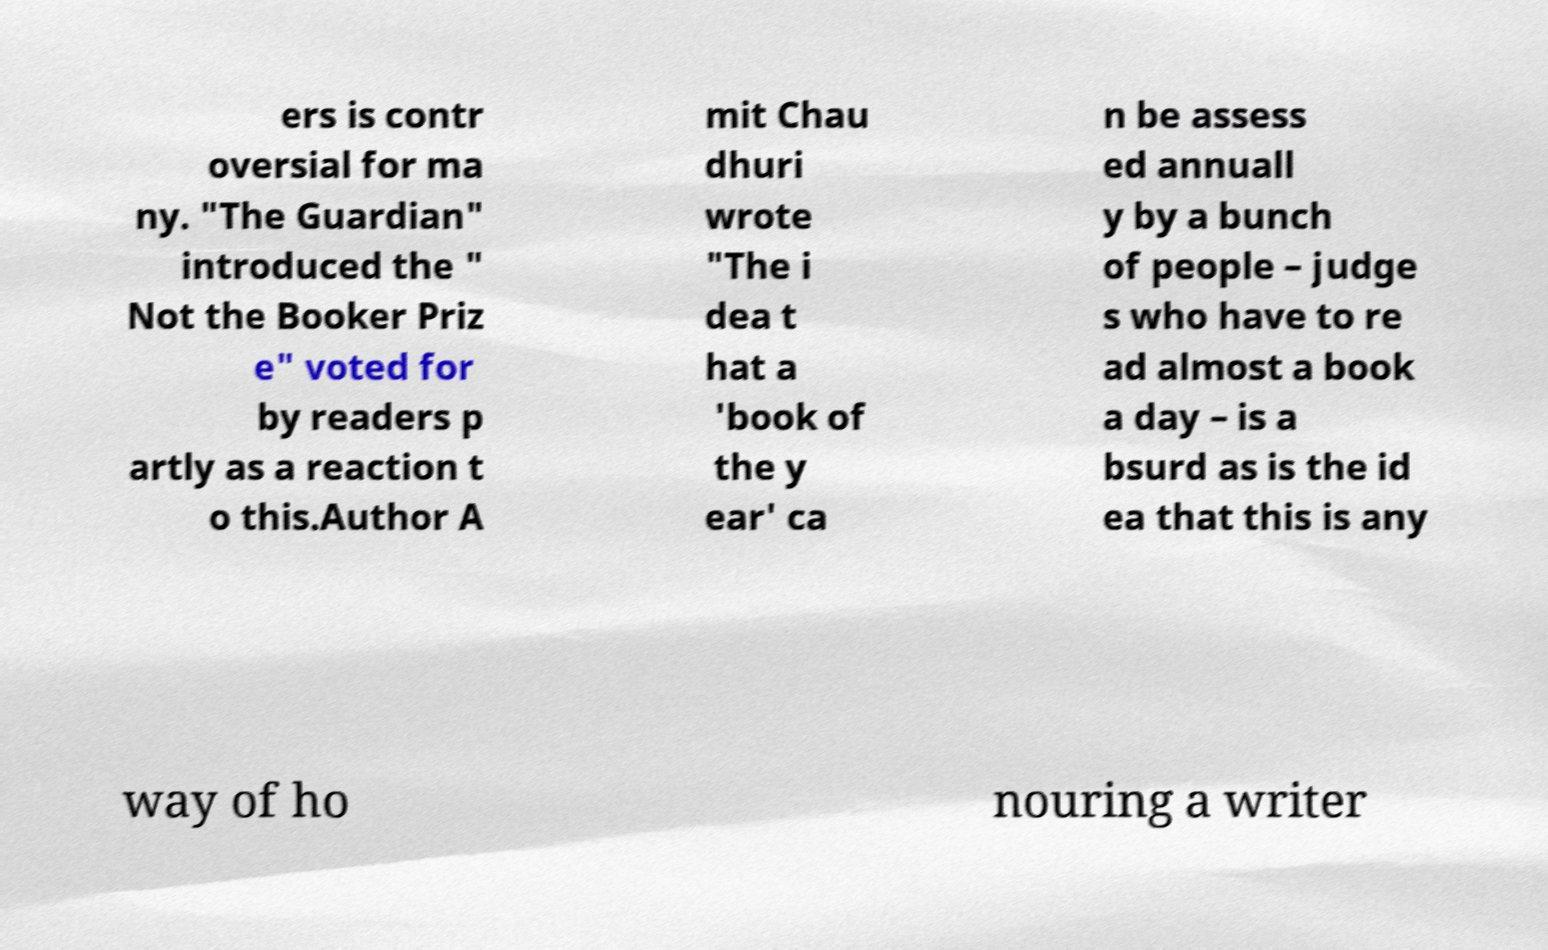Can you accurately transcribe the text from the provided image for me? ers is contr oversial for ma ny. "The Guardian" introduced the " Not the Booker Priz e" voted for by readers p artly as a reaction t o this.Author A mit Chau dhuri wrote "The i dea t hat a 'book of the y ear' ca n be assess ed annuall y by a bunch of people – judge s who have to re ad almost a book a day – is a bsurd as is the id ea that this is any way of ho nouring a writer 